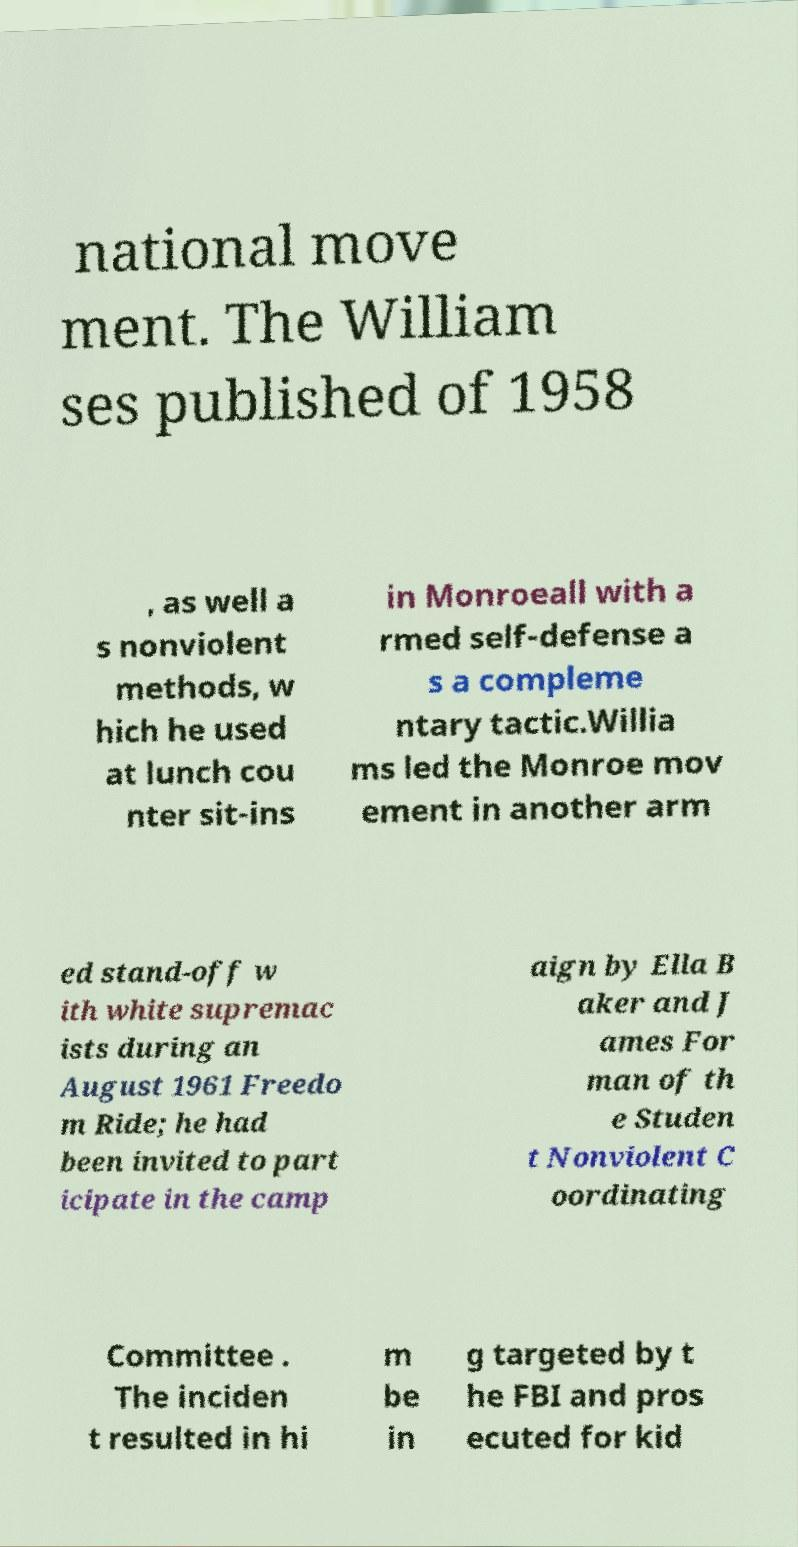Could you assist in decoding the text presented in this image and type it out clearly? national move ment. The William ses published of 1958 , as well a s nonviolent methods, w hich he used at lunch cou nter sit-ins in Monroeall with a rmed self-defense a s a compleme ntary tactic.Willia ms led the Monroe mov ement in another arm ed stand-off w ith white supremac ists during an August 1961 Freedo m Ride; he had been invited to part icipate in the camp aign by Ella B aker and J ames For man of th e Studen t Nonviolent C oordinating Committee . The inciden t resulted in hi m be in g targeted by t he FBI and pros ecuted for kid 